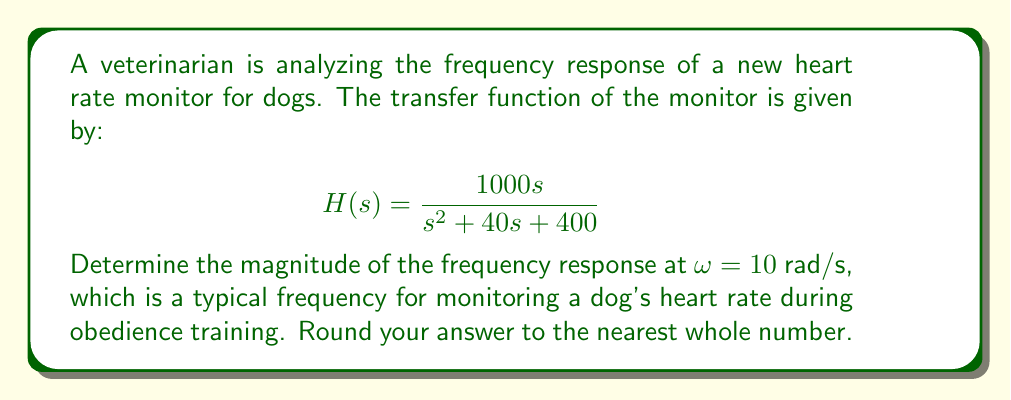Can you solve this math problem? To find the magnitude of the frequency response, we need to follow these steps:

1) The frequency response is obtained by substituting $s = jω$ into the transfer function:

   $$H(jω) = \frac{1000jω}{(jω)^2 + 40jω + 400}$$

2) For ω = 10 rad/s:

   $$H(j10) = \frac{1000j10}{(j10)^2 + 40j10 + 400}$$

3) Simplify the denominator:
   
   $$H(j10) = \frac{10000j}{-100 + 400j + 400} = \frac{10000j}{300 + 400j}$$

4) To find the magnitude, we use the formula:

   $$|H(jω)| = \sqrt{\frac{(\text{Real part})^2 + (\text{Imaginary part})^2}{(\text{Real part of denominator})^2 + (\text{Imaginary part of denominator})^2}}$$

5) In this case:

   $$|H(j10)| = \sqrt{\frac{0^2 + 10000^2}{300^2 + 400^2}} = \sqrt{\frac{100000000}{250000}} = \sqrt{400} = 20$$

6) Therefore, the magnitude of the frequency response at ω = 10 rad/s is 20.
Answer: 20 